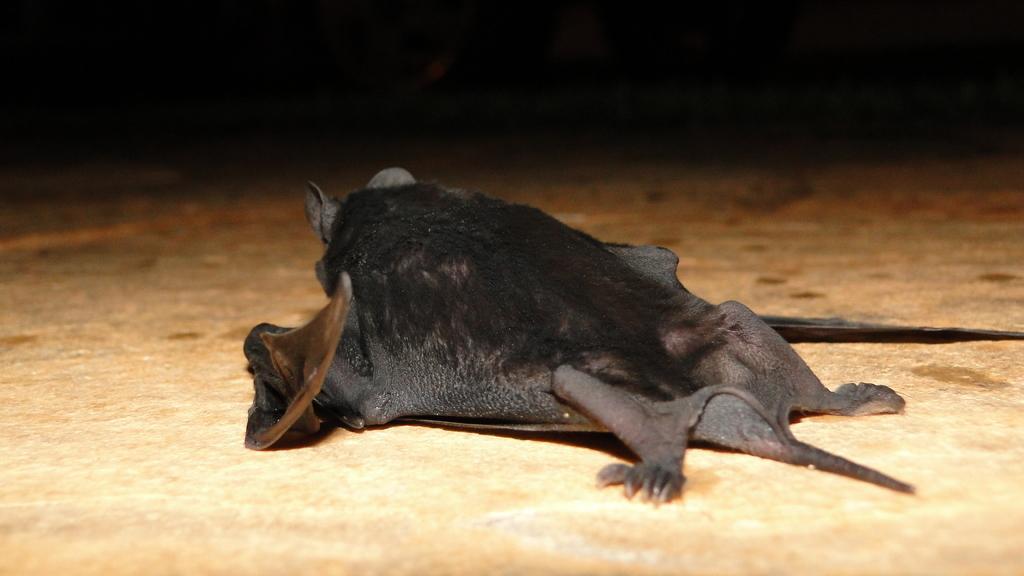How would you summarize this image in a sentence or two? In the picture I can see bat which is on the floor. 